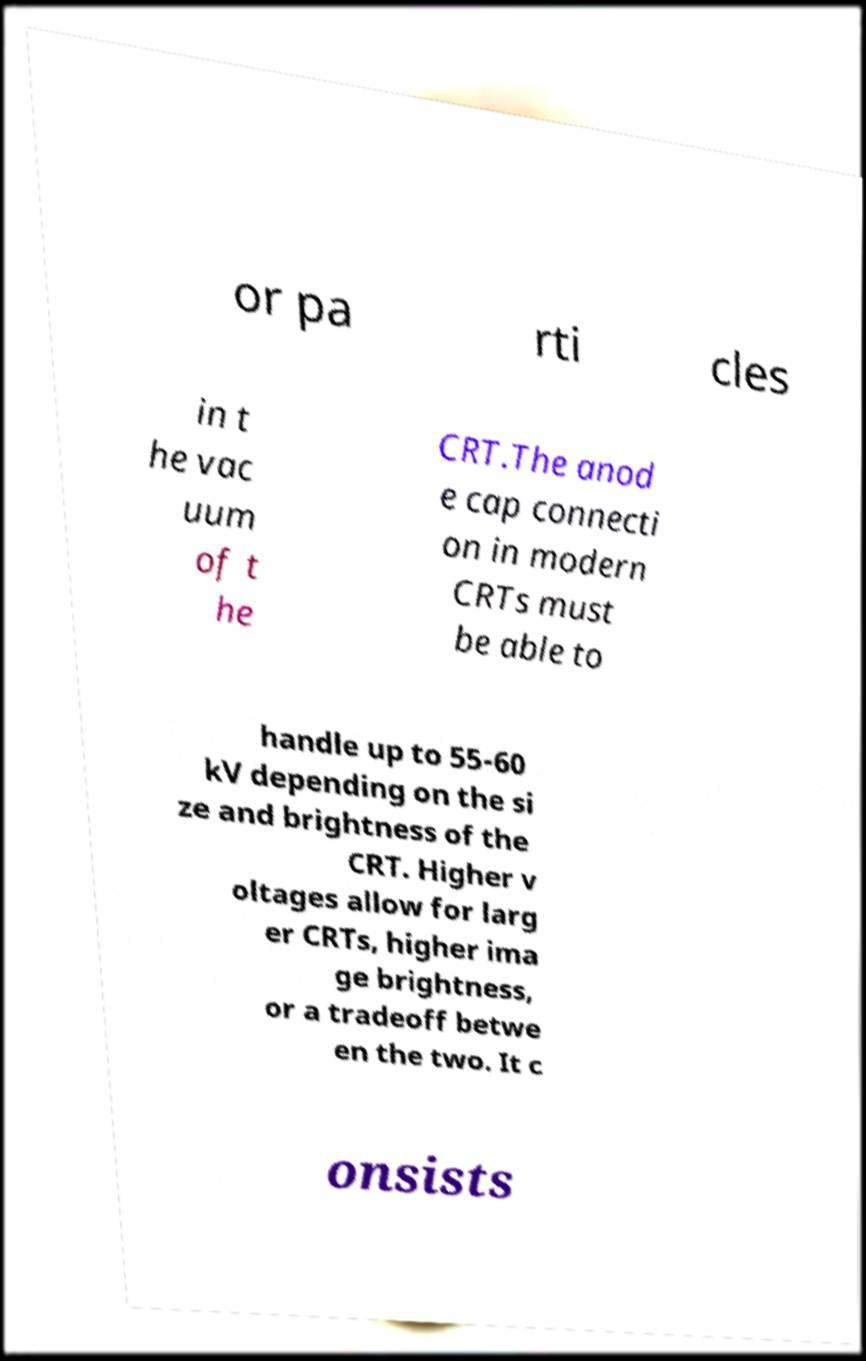Please identify and transcribe the text found in this image. or pa rti cles in t he vac uum of t he CRT.The anod e cap connecti on in modern CRTs must be able to handle up to 55-60 kV depending on the si ze and brightness of the CRT. Higher v oltages allow for larg er CRTs, higher ima ge brightness, or a tradeoff betwe en the two. It c onsists 